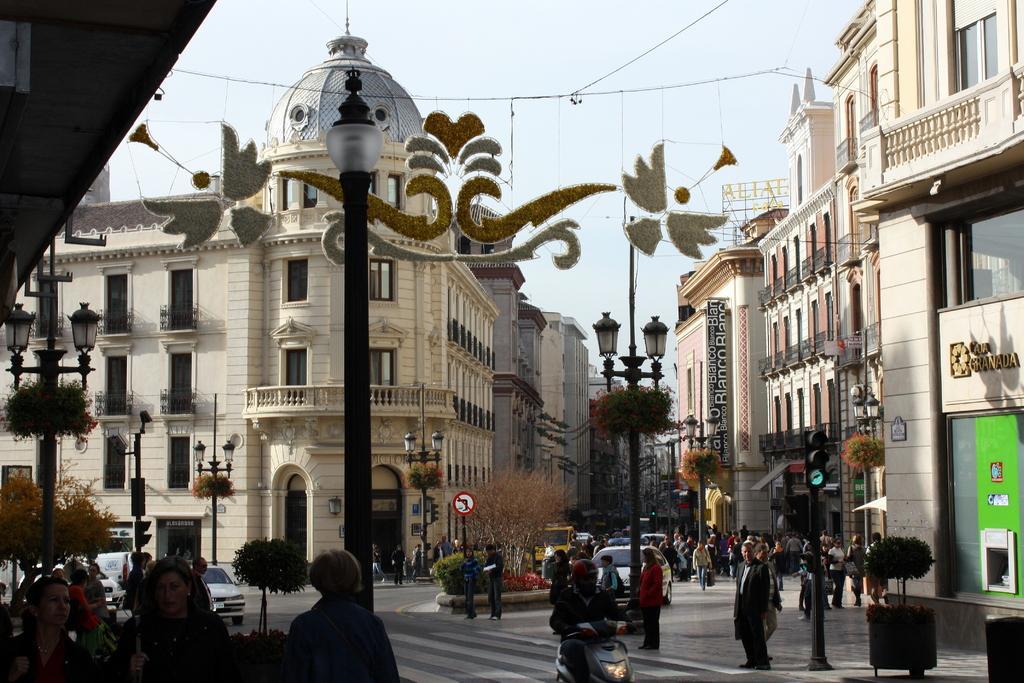Could you give a brief overview of what you see in this image? In the foreground of this image, there are few people on the side path and we can also see few poles, vehicles moving on the road, a sign board, trees and buildings. At the top, there are cables and the sky. 